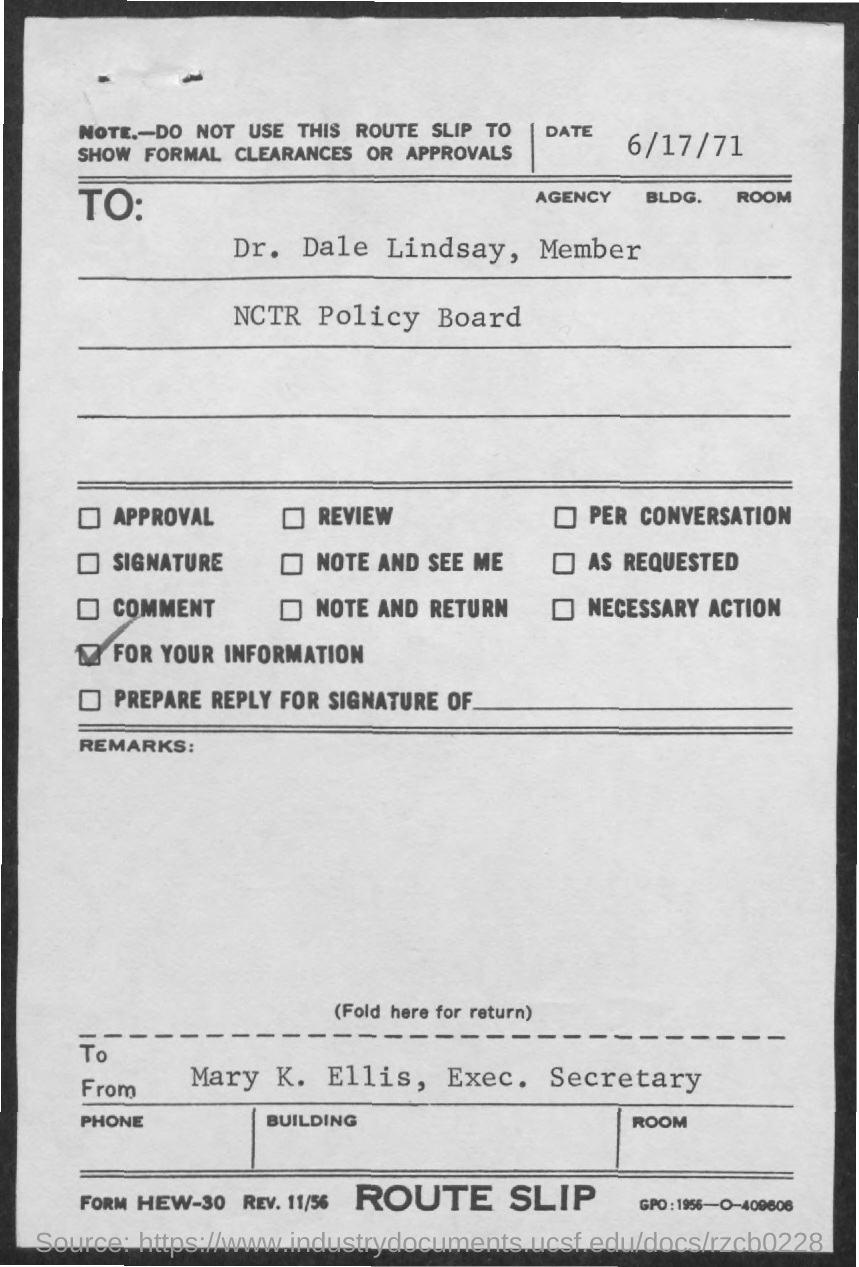Draw attention to some important aspects in this diagram. Dr. Dale Lindsay is a member of the NCTR policy board. The date mentioned in the given letter is 6/17/71. This letter was written to Dr. Dale Lindsay. 